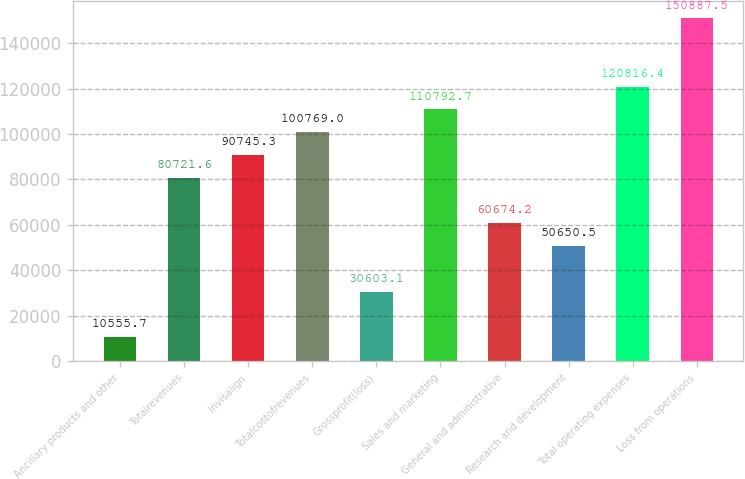<chart> <loc_0><loc_0><loc_500><loc_500><bar_chart><fcel>Ancillary products and other<fcel>Totalrevenues<fcel>Invisalign<fcel>Totalcostofrevenues<fcel>Grossprofit(loss)<fcel>Sales and marketing<fcel>General and administrative<fcel>Research and development<fcel>Total operating expenses<fcel>Loss from operations<nl><fcel>10555.7<fcel>80721.6<fcel>90745.3<fcel>100769<fcel>30603.1<fcel>110793<fcel>60674.2<fcel>50650.5<fcel>120816<fcel>150888<nl></chart> 